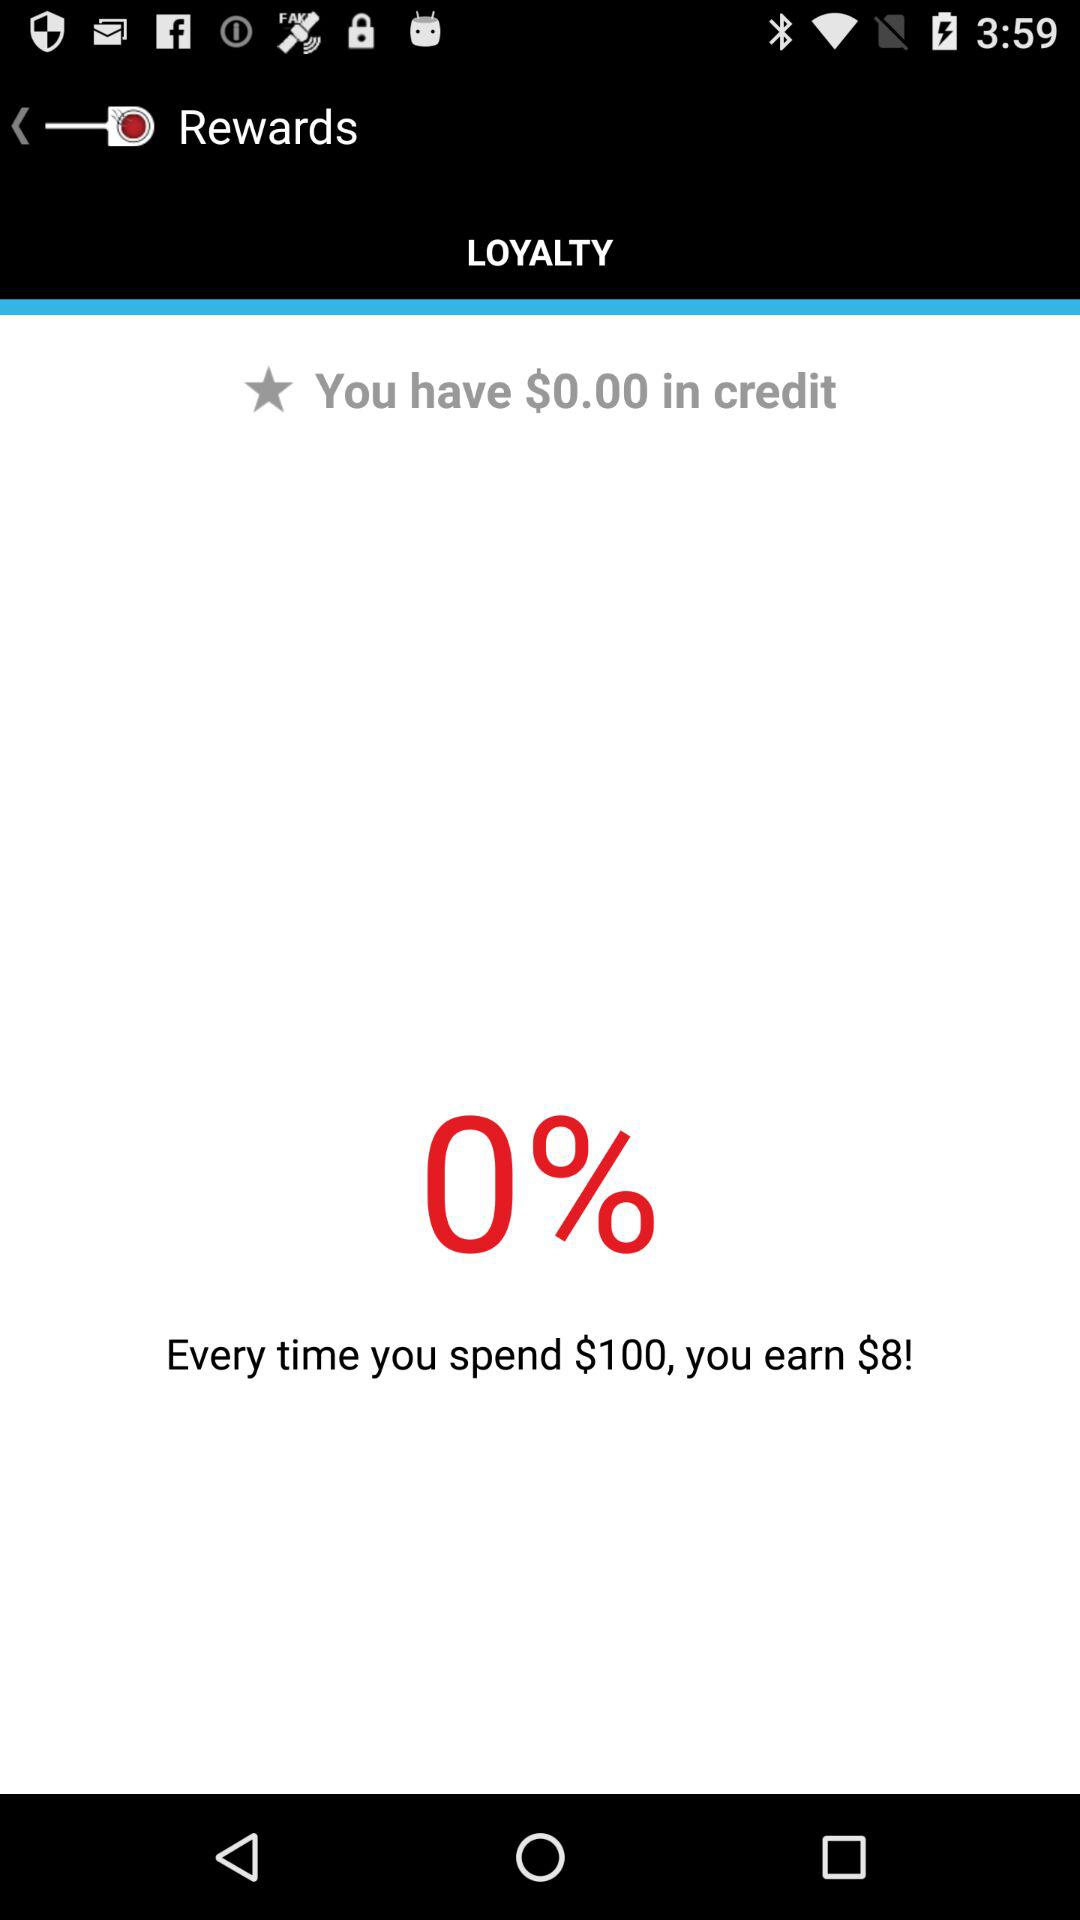How many dollars do you earn for every $100 you spend?
Answer the question using a single word or phrase. 8 